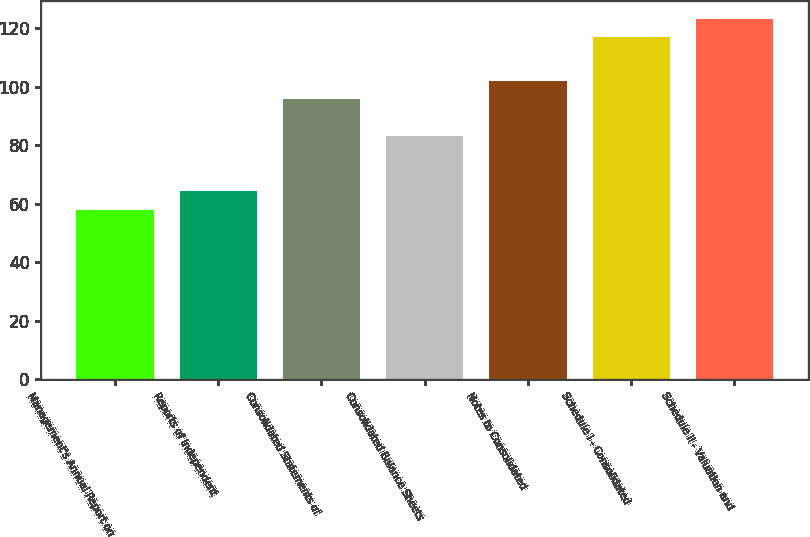<chart> <loc_0><loc_0><loc_500><loc_500><bar_chart><fcel>Management's Annual Report on<fcel>Reports of Independent<fcel>Consolidated Statements of<fcel>Consolidated Balance Sheets<fcel>Notes to Consolidated<fcel>Schedule I - Consolidated<fcel>Schedule II - Valuation and<nl><fcel>58<fcel>64.3<fcel>95.8<fcel>83.2<fcel>102.1<fcel>117<fcel>123.3<nl></chart> 